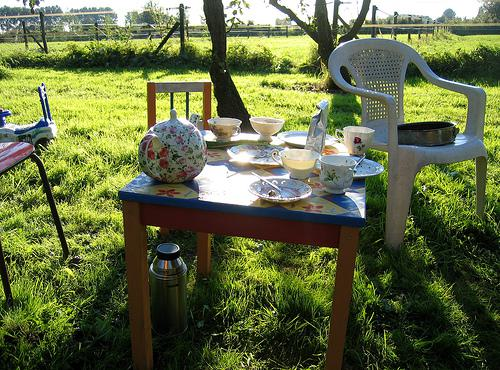What does the kettle suggest about the gathering? The presence of a thermos kettle among the table items suggests the gathering is informal and possibly family-oriented, designed to enjoy warm beverages outdoors over an extended period, implying a relaxed, cozy atmosphere. 